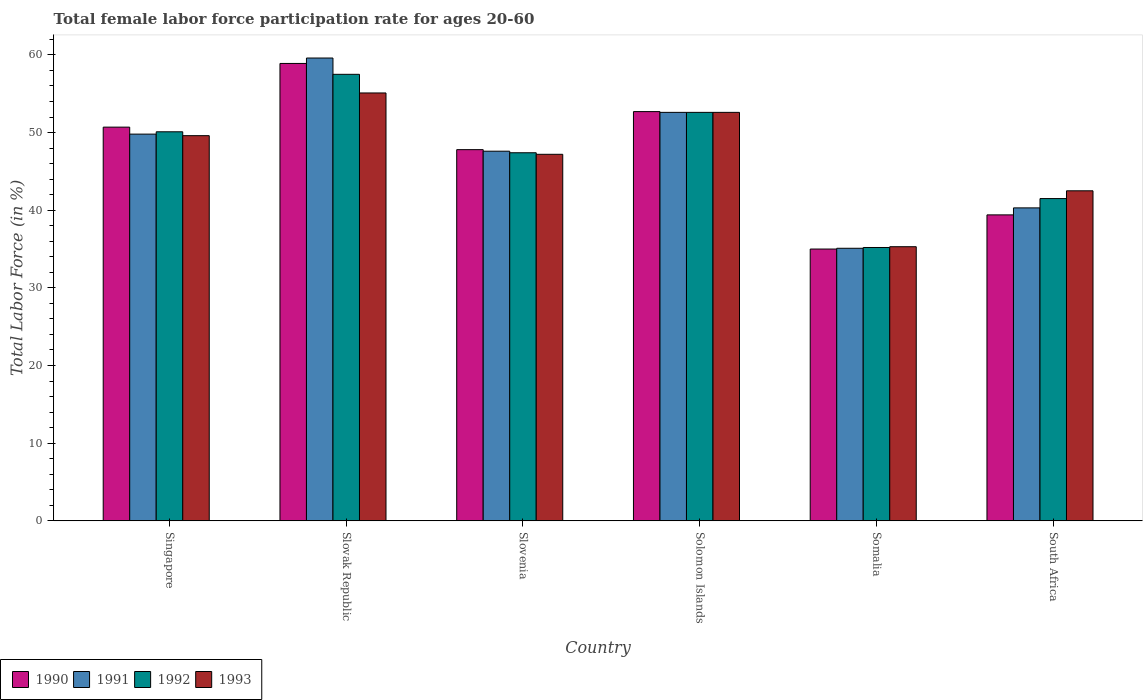How many groups of bars are there?
Ensure brevity in your answer.  6. What is the label of the 3rd group of bars from the left?
Offer a terse response. Slovenia. What is the female labor force participation rate in 1990 in Slovak Republic?
Make the answer very short. 58.9. Across all countries, what is the maximum female labor force participation rate in 1991?
Make the answer very short. 59.6. Across all countries, what is the minimum female labor force participation rate in 1993?
Provide a short and direct response. 35.3. In which country was the female labor force participation rate in 1992 maximum?
Ensure brevity in your answer.  Slovak Republic. In which country was the female labor force participation rate in 1993 minimum?
Provide a succinct answer. Somalia. What is the total female labor force participation rate in 1993 in the graph?
Your answer should be compact. 282.3. What is the difference between the female labor force participation rate in 1993 in Slovak Republic and that in Solomon Islands?
Make the answer very short. 2.5. What is the difference between the female labor force participation rate in 1993 in South Africa and the female labor force participation rate in 1992 in Solomon Islands?
Provide a succinct answer. -10.1. What is the average female labor force participation rate in 1991 per country?
Provide a short and direct response. 47.5. What is the difference between the female labor force participation rate of/in 1991 and female labor force participation rate of/in 1993 in South Africa?
Provide a succinct answer. -2.2. What is the ratio of the female labor force participation rate in 1990 in Singapore to that in Slovak Republic?
Keep it short and to the point. 0.86. Is the difference between the female labor force participation rate in 1991 in Singapore and South Africa greater than the difference between the female labor force participation rate in 1993 in Singapore and South Africa?
Provide a short and direct response. Yes. What is the difference between the highest and the second highest female labor force participation rate in 1991?
Keep it short and to the point. -9.8. What is the difference between the highest and the lowest female labor force participation rate in 1991?
Offer a terse response. 24.5. In how many countries, is the female labor force participation rate in 1990 greater than the average female labor force participation rate in 1990 taken over all countries?
Make the answer very short. 4. What does the 1st bar from the left in Slovenia represents?
Make the answer very short. 1990. Is it the case that in every country, the sum of the female labor force participation rate in 1990 and female labor force participation rate in 1992 is greater than the female labor force participation rate in 1993?
Ensure brevity in your answer.  Yes. How many bars are there?
Give a very brief answer. 24. Are the values on the major ticks of Y-axis written in scientific E-notation?
Provide a short and direct response. No. Does the graph contain grids?
Offer a terse response. No. Where does the legend appear in the graph?
Ensure brevity in your answer.  Bottom left. What is the title of the graph?
Your response must be concise. Total female labor force participation rate for ages 20-60. Does "2014" appear as one of the legend labels in the graph?
Offer a very short reply. No. What is the Total Labor Force (in %) in 1990 in Singapore?
Your answer should be very brief. 50.7. What is the Total Labor Force (in %) of 1991 in Singapore?
Give a very brief answer. 49.8. What is the Total Labor Force (in %) of 1992 in Singapore?
Keep it short and to the point. 50.1. What is the Total Labor Force (in %) in 1993 in Singapore?
Make the answer very short. 49.6. What is the Total Labor Force (in %) of 1990 in Slovak Republic?
Give a very brief answer. 58.9. What is the Total Labor Force (in %) in 1991 in Slovak Republic?
Your answer should be compact. 59.6. What is the Total Labor Force (in %) in 1992 in Slovak Republic?
Offer a terse response. 57.5. What is the Total Labor Force (in %) in 1993 in Slovak Republic?
Your answer should be very brief. 55.1. What is the Total Labor Force (in %) in 1990 in Slovenia?
Provide a succinct answer. 47.8. What is the Total Labor Force (in %) of 1991 in Slovenia?
Provide a short and direct response. 47.6. What is the Total Labor Force (in %) of 1992 in Slovenia?
Offer a very short reply. 47.4. What is the Total Labor Force (in %) of 1993 in Slovenia?
Your answer should be compact. 47.2. What is the Total Labor Force (in %) in 1990 in Solomon Islands?
Your answer should be very brief. 52.7. What is the Total Labor Force (in %) in 1991 in Solomon Islands?
Give a very brief answer. 52.6. What is the Total Labor Force (in %) in 1992 in Solomon Islands?
Give a very brief answer. 52.6. What is the Total Labor Force (in %) of 1993 in Solomon Islands?
Your response must be concise. 52.6. What is the Total Labor Force (in %) in 1990 in Somalia?
Provide a succinct answer. 35. What is the Total Labor Force (in %) of 1991 in Somalia?
Give a very brief answer. 35.1. What is the Total Labor Force (in %) of 1992 in Somalia?
Offer a very short reply. 35.2. What is the Total Labor Force (in %) of 1993 in Somalia?
Provide a succinct answer. 35.3. What is the Total Labor Force (in %) of 1990 in South Africa?
Offer a terse response. 39.4. What is the Total Labor Force (in %) in 1991 in South Africa?
Keep it short and to the point. 40.3. What is the Total Labor Force (in %) in 1992 in South Africa?
Ensure brevity in your answer.  41.5. What is the Total Labor Force (in %) in 1993 in South Africa?
Ensure brevity in your answer.  42.5. Across all countries, what is the maximum Total Labor Force (in %) in 1990?
Your answer should be very brief. 58.9. Across all countries, what is the maximum Total Labor Force (in %) in 1991?
Make the answer very short. 59.6. Across all countries, what is the maximum Total Labor Force (in %) in 1992?
Offer a very short reply. 57.5. Across all countries, what is the maximum Total Labor Force (in %) in 1993?
Give a very brief answer. 55.1. Across all countries, what is the minimum Total Labor Force (in %) in 1990?
Provide a succinct answer. 35. Across all countries, what is the minimum Total Labor Force (in %) of 1991?
Offer a terse response. 35.1. Across all countries, what is the minimum Total Labor Force (in %) of 1992?
Ensure brevity in your answer.  35.2. Across all countries, what is the minimum Total Labor Force (in %) in 1993?
Ensure brevity in your answer.  35.3. What is the total Total Labor Force (in %) in 1990 in the graph?
Your response must be concise. 284.5. What is the total Total Labor Force (in %) in 1991 in the graph?
Keep it short and to the point. 285. What is the total Total Labor Force (in %) of 1992 in the graph?
Make the answer very short. 284.3. What is the total Total Labor Force (in %) in 1993 in the graph?
Offer a terse response. 282.3. What is the difference between the Total Labor Force (in %) of 1990 in Singapore and that in Slovak Republic?
Keep it short and to the point. -8.2. What is the difference between the Total Labor Force (in %) in 1991 in Singapore and that in Slovak Republic?
Keep it short and to the point. -9.8. What is the difference between the Total Labor Force (in %) in 1992 in Singapore and that in Slovak Republic?
Give a very brief answer. -7.4. What is the difference between the Total Labor Force (in %) of 1990 in Singapore and that in Slovenia?
Your answer should be compact. 2.9. What is the difference between the Total Labor Force (in %) in 1992 in Singapore and that in Slovenia?
Offer a very short reply. 2.7. What is the difference between the Total Labor Force (in %) in 1990 in Singapore and that in Solomon Islands?
Your answer should be compact. -2. What is the difference between the Total Labor Force (in %) in 1991 in Singapore and that in Solomon Islands?
Provide a short and direct response. -2.8. What is the difference between the Total Labor Force (in %) of 1993 in Singapore and that in Solomon Islands?
Make the answer very short. -3. What is the difference between the Total Labor Force (in %) of 1991 in Singapore and that in Somalia?
Keep it short and to the point. 14.7. What is the difference between the Total Labor Force (in %) in 1992 in Singapore and that in Somalia?
Your answer should be compact. 14.9. What is the difference between the Total Labor Force (in %) in 1992 in Singapore and that in South Africa?
Your answer should be compact. 8.6. What is the difference between the Total Labor Force (in %) of 1992 in Slovak Republic and that in Slovenia?
Offer a terse response. 10.1. What is the difference between the Total Labor Force (in %) of 1990 in Slovak Republic and that in Solomon Islands?
Ensure brevity in your answer.  6.2. What is the difference between the Total Labor Force (in %) of 1991 in Slovak Republic and that in Solomon Islands?
Provide a short and direct response. 7. What is the difference between the Total Labor Force (in %) in 1993 in Slovak Republic and that in Solomon Islands?
Provide a succinct answer. 2.5. What is the difference between the Total Labor Force (in %) in 1990 in Slovak Republic and that in Somalia?
Your response must be concise. 23.9. What is the difference between the Total Labor Force (in %) of 1991 in Slovak Republic and that in Somalia?
Make the answer very short. 24.5. What is the difference between the Total Labor Force (in %) of 1992 in Slovak Republic and that in Somalia?
Make the answer very short. 22.3. What is the difference between the Total Labor Force (in %) of 1993 in Slovak Republic and that in Somalia?
Give a very brief answer. 19.8. What is the difference between the Total Labor Force (in %) of 1991 in Slovak Republic and that in South Africa?
Your response must be concise. 19.3. What is the difference between the Total Labor Force (in %) of 1992 in Slovak Republic and that in South Africa?
Keep it short and to the point. 16. What is the difference between the Total Labor Force (in %) in 1993 in Slovak Republic and that in South Africa?
Make the answer very short. 12.6. What is the difference between the Total Labor Force (in %) of 1990 in Slovenia and that in Solomon Islands?
Offer a very short reply. -4.9. What is the difference between the Total Labor Force (in %) in 1991 in Slovenia and that in Solomon Islands?
Ensure brevity in your answer.  -5. What is the difference between the Total Labor Force (in %) of 1990 in Slovenia and that in Somalia?
Keep it short and to the point. 12.8. What is the difference between the Total Labor Force (in %) of 1992 in Slovenia and that in Somalia?
Offer a very short reply. 12.2. What is the difference between the Total Labor Force (in %) of 1993 in Slovenia and that in South Africa?
Your answer should be very brief. 4.7. What is the difference between the Total Labor Force (in %) of 1990 in Solomon Islands and that in Somalia?
Give a very brief answer. 17.7. What is the difference between the Total Labor Force (in %) of 1991 in Solomon Islands and that in Somalia?
Ensure brevity in your answer.  17.5. What is the difference between the Total Labor Force (in %) in 1993 in Solomon Islands and that in Somalia?
Offer a very short reply. 17.3. What is the difference between the Total Labor Force (in %) of 1990 in Solomon Islands and that in South Africa?
Ensure brevity in your answer.  13.3. What is the difference between the Total Labor Force (in %) in 1992 in Solomon Islands and that in South Africa?
Your answer should be very brief. 11.1. What is the difference between the Total Labor Force (in %) in 1993 in Solomon Islands and that in South Africa?
Your answer should be compact. 10.1. What is the difference between the Total Labor Force (in %) in 1990 in Somalia and that in South Africa?
Give a very brief answer. -4.4. What is the difference between the Total Labor Force (in %) in 1993 in Somalia and that in South Africa?
Your answer should be compact. -7.2. What is the difference between the Total Labor Force (in %) of 1990 in Singapore and the Total Labor Force (in %) of 1991 in Slovak Republic?
Keep it short and to the point. -8.9. What is the difference between the Total Labor Force (in %) in 1990 in Singapore and the Total Labor Force (in %) in 1992 in Slovak Republic?
Your response must be concise. -6.8. What is the difference between the Total Labor Force (in %) in 1991 in Singapore and the Total Labor Force (in %) in 1992 in Slovak Republic?
Ensure brevity in your answer.  -7.7. What is the difference between the Total Labor Force (in %) of 1991 in Singapore and the Total Labor Force (in %) of 1993 in Slovak Republic?
Your answer should be very brief. -5.3. What is the difference between the Total Labor Force (in %) in 1990 in Singapore and the Total Labor Force (in %) in 1992 in Slovenia?
Offer a terse response. 3.3. What is the difference between the Total Labor Force (in %) of 1990 in Singapore and the Total Labor Force (in %) of 1993 in Slovenia?
Provide a short and direct response. 3.5. What is the difference between the Total Labor Force (in %) of 1991 in Singapore and the Total Labor Force (in %) of 1992 in Slovenia?
Give a very brief answer. 2.4. What is the difference between the Total Labor Force (in %) in 1991 in Singapore and the Total Labor Force (in %) in 1993 in Slovenia?
Ensure brevity in your answer.  2.6. What is the difference between the Total Labor Force (in %) of 1992 in Singapore and the Total Labor Force (in %) of 1993 in Slovenia?
Your response must be concise. 2.9. What is the difference between the Total Labor Force (in %) of 1990 in Singapore and the Total Labor Force (in %) of 1992 in Solomon Islands?
Offer a terse response. -1.9. What is the difference between the Total Labor Force (in %) in 1991 in Singapore and the Total Labor Force (in %) in 1993 in Solomon Islands?
Make the answer very short. -2.8. What is the difference between the Total Labor Force (in %) in 1992 in Singapore and the Total Labor Force (in %) in 1993 in Solomon Islands?
Offer a terse response. -2.5. What is the difference between the Total Labor Force (in %) of 1991 in Singapore and the Total Labor Force (in %) of 1992 in Somalia?
Your answer should be very brief. 14.6. What is the difference between the Total Labor Force (in %) of 1991 in Singapore and the Total Labor Force (in %) of 1993 in Somalia?
Your response must be concise. 14.5. What is the difference between the Total Labor Force (in %) of 1992 in Singapore and the Total Labor Force (in %) of 1993 in Somalia?
Your response must be concise. 14.8. What is the difference between the Total Labor Force (in %) in 1990 in Singapore and the Total Labor Force (in %) in 1992 in South Africa?
Provide a succinct answer. 9.2. What is the difference between the Total Labor Force (in %) in 1990 in Singapore and the Total Labor Force (in %) in 1993 in South Africa?
Offer a very short reply. 8.2. What is the difference between the Total Labor Force (in %) of 1991 in Singapore and the Total Labor Force (in %) of 1992 in South Africa?
Your answer should be very brief. 8.3. What is the difference between the Total Labor Force (in %) of 1991 in Singapore and the Total Labor Force (in %) of 1993 in South Africa?
Provide a succinct answer. 7.3. What is the difference between the Total Labor Force (in %) in 1990 in Slovak Republic and the Total Labor Force (in %) in 1991 in Slovenia?
Ensure brevity in your answer.  11.3. What is the difference between the Total Labor Force (in %) of 1990 in Slovak Republic and the Total Labor Force (in %) of 1993 in Slovenia?
Ensure brevity in your answer.  11.7. What is the difference between the Total Labor Force (in %) in 1991 in Slovak Republic and the Total Labor Force (in %) in 1992 in Slovenia?
Your answer should be compact. 12.2. What is the difference between the Total Labor Force (in %) of 1992 in Slovak Republic and the Total Labor Force (in %) of 1993 in Slovenia?
Provide a succinct answer. 10.3. What is the difference between the Total Labor Force (in %) of 1991 in Slovak Republic and the Total Labor Force (in %) of 1992 in Solomon Islands?
Your answer should be very brief. 7. What is the difference between the Total Labor Force (in %) of 1991 in Slovak Republic and the Total Labor Force (in %) of 1993 in Solomon Islands?
Provide a succinct answer. 7. What is the difference between the Total Labor Force (in %) in 1992 in Slovak Republic and the Total Labor Force (in %) in 1993 in Solomon Islands?
Offer a very short reply. 4.9. What is the difference between the Total Labor Force (in %) in 1990 in Slovak Republic and the Total Labor Force (in %) in 1991 in Somalia?
Provide a succinct answer. 23.8. What is the difference between the Total Labor Force (in %) of 1990 in Slovak Republic and the Total Labor Force (in %) of 1992 in Somalia?
Keep it short and to the point. 23.7. What is the difference between the Total Labor Force (in %) of 1990 in Slovak Republic and the Total Labor Force (in %) of 1993 in Somalia?
Make the answer very short. 23.6. What is the difference between the Total Labor Force (in %) in 1991 in Slovak Republic and the Total Labor Force (in %) in 1992 in Somalia?
Provide a short and direct response. 24.4. What is the difference between the Total Labor Force (in %) in 1991 in Slovak Republic and the Total Labor Force (in %) in 1993 in Somalia?
Your response must be concise. 24.3. What is the difference between the Total Labor Force (in %) in 1990 in Slovak Republic and the Total Labor Force (in %) in 1992 in South Africa?
Offer a very short reply. 17.4. What is the difference between the Total Labor Force (in %) in 1991 in Slovak Republic and the Total Labor Force (in %) in 1993 in South Africa?
Keep it short and to the point. 17.1. What is the difference between the Total Labor Force (in %) of 1992 in Slovak Republic and the Total Labor Force (in %) of 1993 in South Africa?
Make the answer very short. 15. What is the difference between the Total Labor Force (in %) in 1990 in Slovenia and the Total Labor Force (in %) in 1992 in Solomon Islands?
Provide a succinct answer. -4.8. What is the difference between the Total Labor Force (in %) of 1992 in Slovenia and the Total Labor Force (in %) of 1993 in Solomon Islands?
Keep it short and to the point. -5.2. What is the difference between the Total Labor Force (in %) of 1990 in Slovenia and the Total Labor Force (in %) of 1991 in Somalia?
Make the answer very short. 12.7. What is the difference between the Total Labor Force (in %) of 1990 in Slovenia and the Total Labor Force (in %) of 1992 in Somalia?
Provide a short and direct response. 12.6. What is the difference between the Total Labor Force (in %) of 1991 in Slovenia and the Total Labor Force (in %) of 1993 in Somalia?
Your answer should be very brief. 12.3. What is the difference between the Total Labor Force (in %) of 1992 in Slovenia and the Total Labor Force (in %) of 1993 in Somalia?
Keep it short and to the point. 12.1. What is the difference between the Total Labor Force (in %) of 1990 in Slovenia and the Total Labor Force (in %) of 1991 in South Africa?
Your answer should be compact. 7.5. What is the difference between the Total Labor Force (in %) in 1990 in Slovenia and the Total Labor Force (in %) in 1992 in South Africa?
Provide a succinct answer. 6.3. What is the difference between the Total Labor Force (in %) in 1990 in Slovenia and the Total Labor Force (in %) in 1993 in South Africa?
Provide a short and direct response. 5.3. What is the difference between the Total Labor Force (in %) of 1991 in Slovenia and the Total Labor Force (in %) of 1993 in South Africa?
Give a very brief answer. 5.1. What is the difference between the Total Labor Force (in %) of 1990 in Solomon Islands and the Total Labor Force (in %) of 1991 in Somalia?
Keep it short and to the point. 17.6. What is the difference between the Total Labor Force (in %) of 1990 in Solomon Islands and the Total Labor Force (in %) of 1993 in Somalia?
Give a very brief answer. 17.4. What is the difference between the Total Labor Force (in %) in 1991 in Solomon Islands and the Total Labor Force (in %) in 1992 in Somalia?
Make the answer very short. 17.4. What is the difference between the Total Labor Force (in %) of 1992 in Solomon Islands and the Total Labor Force (in %) of 1993 in Somalia?
Your answer should be compact. 17.3. What is the difference between the Total Labor Force (in %) of 1990 in Solomon Islands and the Total Labor Force (in %) of 1991 in South Africa?
Ensure brevity in your answer.  12.4. What is the difference between the Total Labor Force (in %) of 1990 in Solomon Islands and the Total Labor Force (in %) of 1993 in South Africa?
Provide a short and direct response. 10.2. What is the difference between the Total Labor Force (in %) of 1991 in Solomon Islands and the Total Labor Force (in %) of 1993 in South Africa?
Your response must be concise. 10.1. What is the difference between the Total Labor Force (in %) in 1991 in Somalia and the Total Labor Force (in %) in 1992 in South Africa?
Make the answer very short. -6.4. What is the average Total Labor Force (in %) of 1990 per country?
Provide a short and direct response. 47.42. What is the average Total Labor Force (in %) of 1991 per country?
Provide a succinct answer. 47.5. What is the average Total Labor Force (in %) of 1992 per country?
Keep it short and to the point. 47.38. What is the average Total Labor Force (in %) of 1993 per country?
Ensure brevity in your answer.  47.05. What is the difference between the Total Labor Force (in %) in 1990 and Total Labor Force (in %) in 1991 in Singapore?
Your response must be concise. 0.9. What is the difference between the Total Labor Force (in %) of 1990 and Total Labor Force (in %) of 1992 in Singapore?
Offer a very short reply. 0.6. What is the difference between the Total Labor Force (in %) of 1991 and Total Labor Force (in %) of 1992 in Singapore?
Keep it short and to the point. -0.3. What is the difference between the Total Labor Force (in %) of 1992 and Total Labor Force (in %) of 1993 in Singapore?
Keep it short and to the point. 0.5. What is the difference between the Total Labor Force (in %) in 1990 and Total Labor Force (in %) in 1991 in Slovak Republic?
Your answer should be compact. -0.7. What is the difference between the Total Labor Force (in %) of 1990 and Total Labor Force (in %) of 1993 in Slovak Republic?
Provide a short and direct response. 3.8. What is the difference between the Total Labor Force (in %) in 1991 and Total Labor Force (in %) in 1993 in Slovak Republic?
Provide a succinct answer. 4.5. What is the difference between the Total Labor Force (in %) in 1990 and Total Labor Force (in %) in 1992 in Slovenia?
Ensure brevity in your answer.  0.4. What is the difference between the Total Labor Force (in %) in 1991 and Total Labor Force (in %) in 1992 in Slovenia?
Offer a very short reply. 0.2. What is the difference between the Total Labor Force (in %) in 1992 and Total Labor Force (in %) in 1993 in Slovenia?
Make the answer very short. 0.2. What is the difference between the Total Labor Force (in %) in 1990 and Total Labor Force (in %) in 1992 in Solomon Islands?
Give a very brief answer. 0.1. What is the difference between the Total Labor Force (in %) of 1990 and Total Labor Force (in %) of 1993 in Solomon Islands?
Provide a succinct answer. 0.1. What is the difference between the Total Labor Force (in %) of 1991 and Total Labor Force (in %) of 1992 in Somalia?
Make the answer very short. -0.1. What is the difference between the Total Labor Force (in %) of 1992 and Total Labor Force (in %) of 1993 in Somalia?
Keep it short and to the point. -0.1. What is the difference between the Total Labor Force (in %) in 1990 and Total Labor Force (in %) in 1991 in South Africa?
Your answer should be very brief. -0.9. What is the difference between the Total Labor Force (in %) of 1990 and Total Labor Force (in %) of 1992 in South Africa?
Offer a terse response. -2.1. What is the ratio of the Total Labor Force (in %) of 1990 in Singapore to that in Slovak Republic?
Offer a very short reply. 0.86. What is the ratio of the Total Labor Force (in %) of 1991 in Singapore to that in Slovak Republic?
Make the answer very short. 0.84. What is the ratio of the Total Labor Force (in %) in 1992 in Singapore to that in Slovak Republic?
Provide a succinct answer. 0.87. What is the ratio of the Total Labor Force (in %) of 1993 in Singapore to that in Slovak Republic?
Your answer should be compact. 0.9. What is the ratio of the Total Labor Force (in %) of 1990 in Singapore to that in Slovenia?
Your response must be concise. 1.06. What is the ratio of the Total Labor Force (in %) in 1991 in Singapore to that in Slovenia?
Offer a very short reply. 1.05. What is the ratio of the Total Labor Force (in %) of 1992 in Singapore to that in Slovenia?
Your answer should be very brief. 1.06. What is the ratio of the Total Labor Force (in %) in 1993 in Singapore to that in Slovenia?
Ensure brevity in your answer.  1.05. What is the ratio of the Total Labor Force (in %) of 1991 in Singapore to that in Solomon Islands?
Make the answer very short. 0.95. What is the ratio of the Total Labor Force (in %) in 1992 in Singapore to that in Solomon Islands?
Your response must be concise. 0.95. What is the ratio of the Total Labor Force (in %) of 1993 in Singapore to that in Solomon Islands?
Ensure brevity in your answer.  0.94. What is the ratio of the Total Labor Force (in %) of 1990 in Singapore to that in Somalia?
Your answer should be very brief. 1.45. What is the ratio of the Total Labor Force (in %) in 1991 in Singapore to that in Somalia?
Your answer should be very brief. 1.42. What is the ratio of the Total Labor Force (in %) in 1992 in Singapore to that in Somalia?
Give a very brief answer. 1.42. What is the ratio of the Total Labor Force (in %) of 1993 in Singapore to that in Somalia?
Keep it short and to the point. 1.41. What is the ratio of the Total Labor Force (in %) of 1990 in Singapore to that in South Africa?
Offer a terse response. 1.29. What is the ratio of the Total Labor Force (in %) of 1991 in Singapore to that in South Africa?
Provide a short and direct response. 1.24. What is the ratio of the Total Labor Force (in %) in 1992 in Singapore to that in South Africa?
Keep it short and to the point. 1.21. What is the ratio of the Total Labor Force (in %) of 1993 in Singapore to that in South Africa?
Your response must be concise. 1.17. What is the ratio of the Total Labor Force (in %) of 1990 in Slovak Republic to that in Slovenia?
Provide a short and direct response. 1.23. What is the ratio of the Total Labor Force (in %) in 1991 in Slovak Republic to that in Slovenia?
Keep it short and to the point. 1.25. What is the ratio of the Total Labor Force (in %) in 1992 in Slovak Republic to that in Slovenia?
Offer a very short reply. 1.21. What is the ratio of the Total Labor Force (in %) in 1993 in Slovak Republic to that in Slovenia?
Your response must be concise. 1.17. What is the ratio of the Total Labor Force (in %) of 1990 in Slovak Republic to that in Solomon Islands?
Offer a very short reply. 1.12. What is the ratio of the Total Labor Force (in %) in 1991 in Slovak Republic to that in Solomon Islands?
Your answer should be very brief. 1.13. What is the ratio of the Total Labor Force (in %) in 1992 in Slovak Republic to that in Solomon Islands?
Your answer should be very brief. 1.09. What is the ratio of the Total Labor Force (in %) of 1993 in Slovak Republic to that in Solomon Islands?
Offer a very short reply. 1.05. What is the ratio of the Total Labor Force (in %) of 1990 in Slovak Republic to that in Somalia?
Offer a terse response. 1.68. What is the ratio of the Total Labor Force (in %) in 1991 in Slovak Republic to that in Somalia?
Give a very brief answer. 1.7. What is the ratio of the Total Labor Force (in %) of 1992 in Slovak Republic to that in Somalia?
Provide a succinct answer. 1.63. What is the ratio of the Total Labor Force (in %) in 1993 in Slovak Republic to that in Somalia?
Provide a succinct answer. 1.56. What is the ratio of the Total Labor Force (in %) in 1990 in Slovak Republic to that in South Africa?
Offer a very short reply. 1.49. What is the ratio of the Total Labor Force (in %) of 1991 in Slovak Republic to that in South Africa?
Provide a succinct answer. 1.48. What is the ratio of the Total Labor Force (in %) of 1992 in Slovak Republic to that in South Africa?
Keep it short and to the point. 1.39. What is the ratio of the Total Labor Force (in %) of 1993 in Slovak Republic to that in South Africa?
Your response must be concise. 1.3. What is the ratio of the Total Labor Force (in %) of 1990 in Slovenia to that in Solomon Islands?
Give a very brief answer. 0.91. What is the ratio of the Total Labor Force (in %) in 1991 in Slovenia to that in Solomon Islands?
Your answer should be very brief. 0.9. What is the ratio of the Total Labor Force (in %) of 1992 in Slovenia to that in Solomon Islands?
Your response must be concise. 0.9. What is the ratio of the Total Labor Force (in %) in 1993 in Slovenia to that in Solomon Islands?
Ensure brevity in your answer.  0.9. What is the ratio of the Total Labor Force (in %) of 1990 in Slovenia to that in Somalia?
Provide a succinct answer. 1.37. What is the ratio of the Total Labor Force (in %) of 1991 in Slovenia to that in Somalia?
Give a very brief answer. 1.36. What is the ratio of the Total Labor Force (in %) of 1992 in Slovenia to that in Somalia?
Provide a succinct answer. 1.35. What is the ratio of the Total Labor Force (in %) in 1993 in Slovenia to that in Somalia?
Offer a very short reply. 1.34. What is the ratio of the Total Labor Force (in %) in 1990 in Slovenia to that in South Africa?
Your response must be concise. 1.21. What is the ratio of the Total Labor Force (in %) in 1991 in Slovenia to that in South Africa?
Keep it short and to the point. 1.18. What is the ratio of the Total Labor Force (in %) in 1992 in Slovenia to that in South Africa?
Your answer should be compact. 1.14. What is the ratio of the Total Labor Force (in %) of 1993 in Slovenia to that in South Africa?
Make the answer very short. 1.11. What is the ratio of the Total Labor Force (in %) of 1990 in Solomon Islands to that in Somalia?
Offer a very short reply. 1.51. What is the ratio of the Total Labor Force (in %) of 1991 in Solomon Islands to that in Somalia?
Make the answer very short. 1.5. What is the ratio of the Total Labor Force (in %) of 1992 in Solomon Islands to that in Somalia?
Keep it short and to the point. 1.49. What is the ratio of the Total Labor Force (in %) of 1993 in Solomon Islands to that in Somalia?
Make the answer very short. 1.49. What is the ratio of the Total Labor Force (in %) in 1990 in Solomon Islands to that in South Africa?
Offer a terse response. 1.34. What is the ratio of the Total Labor Force (in %) in 1991 in Solomon Islands to that in South Africa?
Your response must be concise. 1.31. What is the ratio of the Total Labor Force (in %) of 1992 in Solomon Islands to that in South Africa?
Offer a terse response. 1.27. What is the ratio of the Total Labor Force (in %) of 1993 in Solomon Islands to that in South Africa?
Give a very brief answer. 1.24. What is the ratio of the Total Labor Force (in %) in 1990 in Somalia to that in South Africa?
Offer a very short reply. 0.89. What is the ratio of the Total Labor Force (in %) of 1991 in Somalia to that in South Africa?
Make the answer very short. 0.87. What is the ratio of the Total Labor Force (in %) in 1992 in Somalia to that in South Africa?
Ensure brevity in your answer.  0.85. What is the ratio of the Total Labor Force (in %) of 1993 in Somalia to that in South Africa?
Ensure brevity in your answer.  0.83. What is the difference between the highest and the second highest Total Labor Force (in %) of 1990?
Offer a terse response. 6.2. What is the difference between the highest and the second highest Total Labor Force (in %) in 1991?
Your answer should be very brief. 7. What is the difference between the highest and the lowest Total Labor Force (in %) of 1990?
Ensure brevity in your answer.  23.9. What is the difference between the highest and the lowest Total Labor Force (in %) in 1992?
Provide a succinct answer. 22.3. What is the difference between the highest and the lowest Total Labor Force (in %) of 1993?
Your response must be concise. 19.8. 